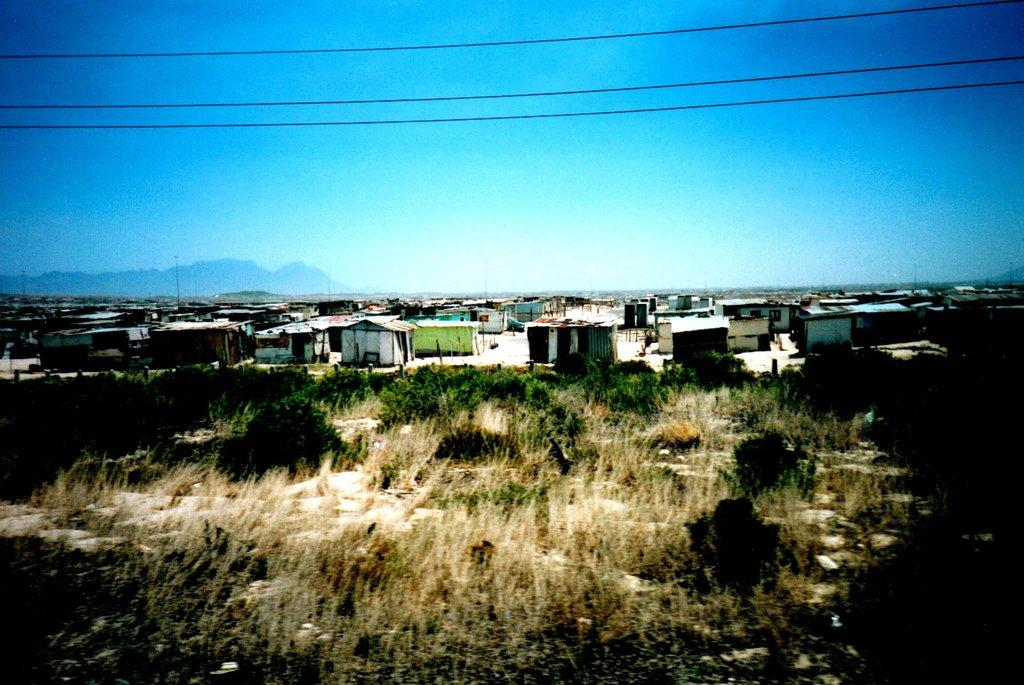What celestial bodies are depicted in the image? There are planets in the image. What type of structures can be seen in the image? There are houses in the image. What else is present in the image besides planets and houses? There are wires in the image. What can be seen in the background of the image? The sky is visible in the background of the image. What type of toothpaste is being used to clean the brass in the image? There is no toothpaste or brass present in the image. What type of coil is visible in the image? There is no coil present in the image. 